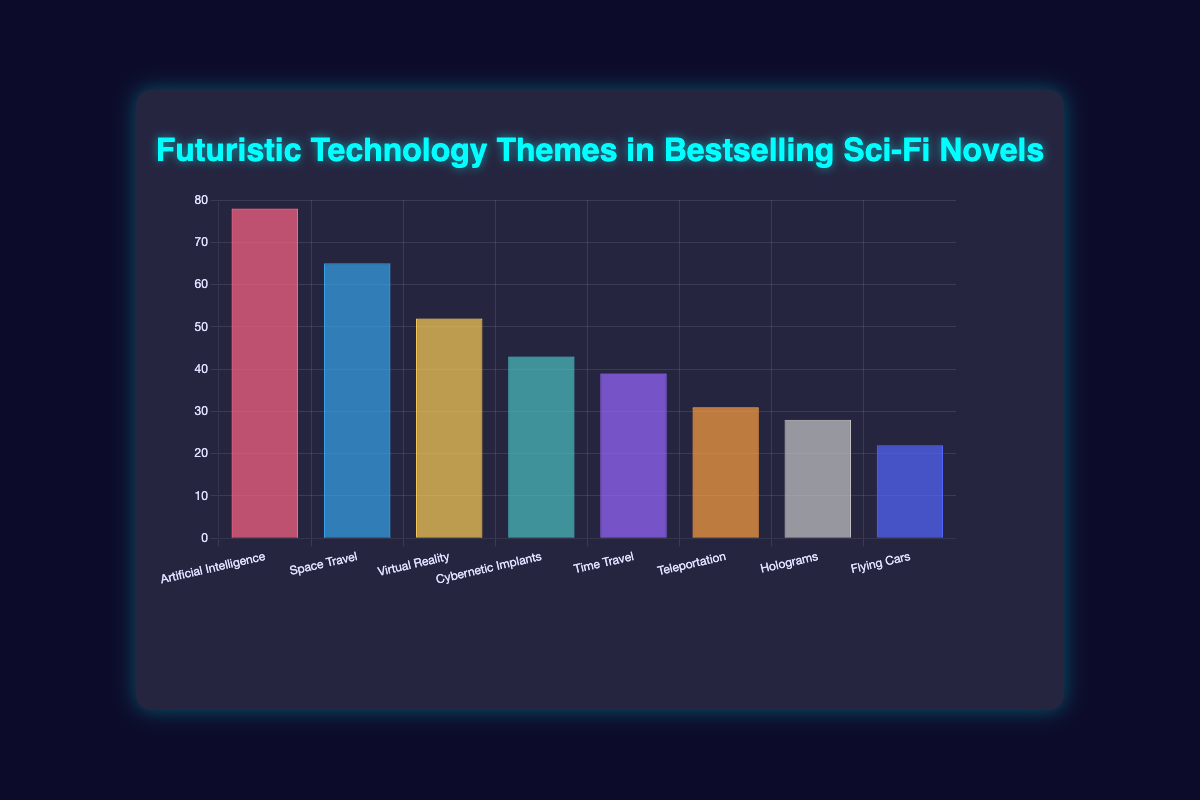What is the most common futuristic technology theme in bestselling sci-fi novels? The chart shows the frequency of different futuristic technology themes. The highest bar represents Artificial Intelligence with a frequency of 78.
Answer: Artificial Intelligence What theme has the second-highest frequency, and how often does it appear? The chart's second-highest bar represents Space Travel with a frequency of 65.
Answer: Space Travel, 65 What is the frequency difference between the most common theme and the least common theme? The most common theme, Artificial Intelligence, appears 78 times, and the least common theme, Flying Cars, appears 22 times. The difference is 78 - 22 = 56.
Answer: 56 Which themes appear more often: Cybernetic Implants or Virtual Reality? The chart shows Virtual Reality with a frequency of 52 and Cybernetic Implants with 43. Since 52 > 43, Virtual Reality appears more often.
Answer: Virtual Reality How many themes have a frequency greater than 40? The chart lists themes with frequencies: 78, 65, 52, 43, 39, 31, 28, and 22. Four themes (Artificial Intelligence, Space Travel, Virtual Reality, Cybernetic Implants) have frequencies greater than 40.
Answer: 4 What is the combined frequency of Time Travel and Teleportation themes? Time Travel has a frequency of 39, and Teleportation has a frequency of 31. The combined frequency is 39 + 31 = 70.
Answer: 70 Which theme corresponds to the emoji 🦾, and what is its frequency? The chart shows 🦾 representing Cybernetic Implants with a frequency of 43.
Answer: Cybernetic Implants, 43 What is the average frequency of all the themes presented in the chart? The sum of frequencies (78 + 65 + 52 + 43 + 39 + 31 + 28 + 22) = 358. There are 8 themes. The average is 358 / 8 = 44.75.
Answer: 44.75 Are there more themes with a frequency above or below 30? Themes with frequencies above 30 are 5 (Artificial Intelligence, Space Travel, Virtual Reality, Cybernetic Implants, Time Travel). Themes with frequencies below 30 are 3 (Teleportation, Holograms, Flying Cars). There are more themes above 30.
Answer: Above 30 Which two themes combined have a frequency close to 100? Combining frequencies, we find 52 (Virtual Reality) + 43 (Cybernetic Implants) = 95, which is the closest to 100.
Answer: Virtual Reality and Cybernetic Implants 